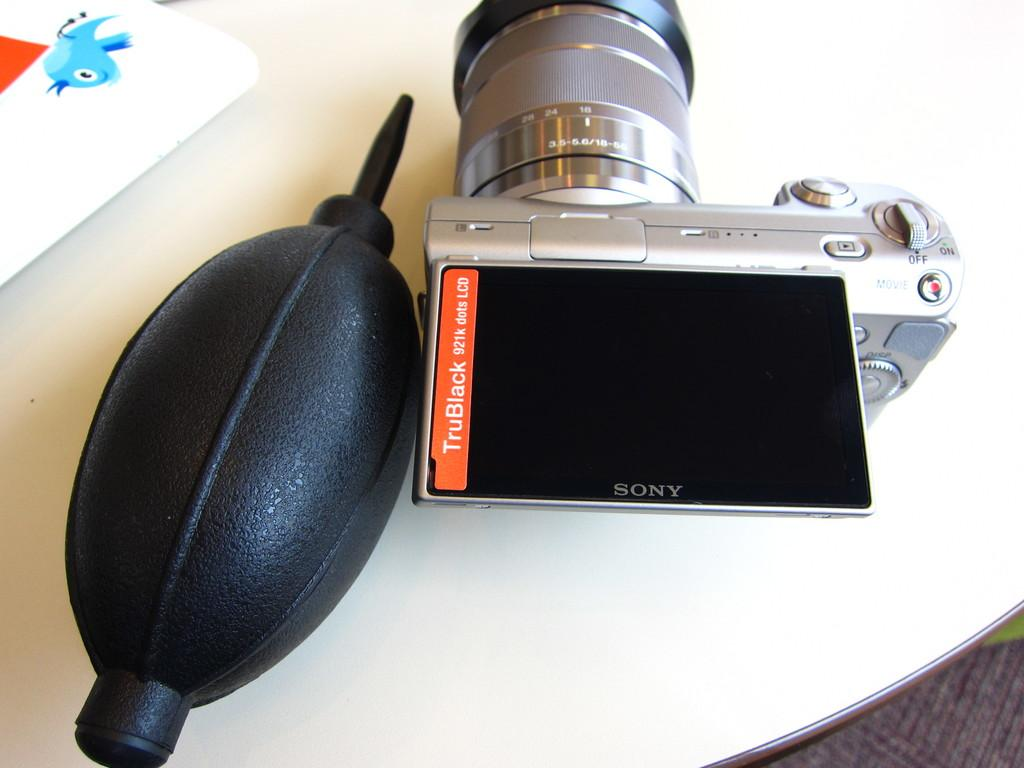What type of camera is visible in the image? There is a Sony camera in the image. What color is the object next to the camera? The object is black in color. What is the surface on which the objects are placed? The objects are placed on a table. What is the color of the table? The table appears to be white in color. What is the purpose of the board in the image? The purpose of the board is not specified in the facts, but it is present in the image. What type of stage is visible in the image? There is no stage present in the image. 